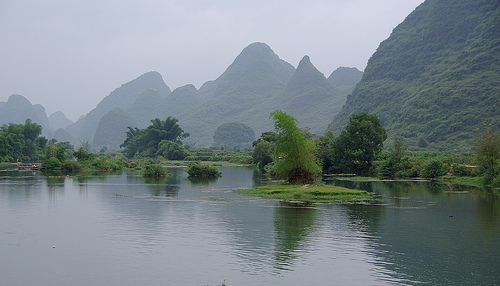<image>
Is there a mountain in front of the tree? No. The mountain is not in front of the tree. The spatial positioning shows a different relationship between these objects. 